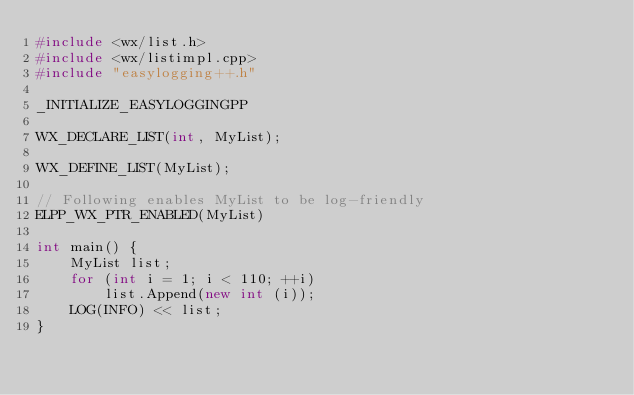Convert code to text. <code><loc_0><loc_0><loc_500><loc_500><_C++_>#include <wx/list.h>
#include <wx/listimpl.cpp>
#include "easylogging++.h"

_INITIALIZE_EASYLOGGINGPP

WX_DECLARE_LIST(int, MyList);

WX_DEFINE_LIST(MyList);

// Following enables MyList to be log-friendly
ELPP_WX_PTR_ENABLED(MyList)

int main() {
    MyList list;
    for (int i = 1; i < 110; ++i)
        list.Append(new int (i));
    LOG(INFO) << list;
}
</code> 